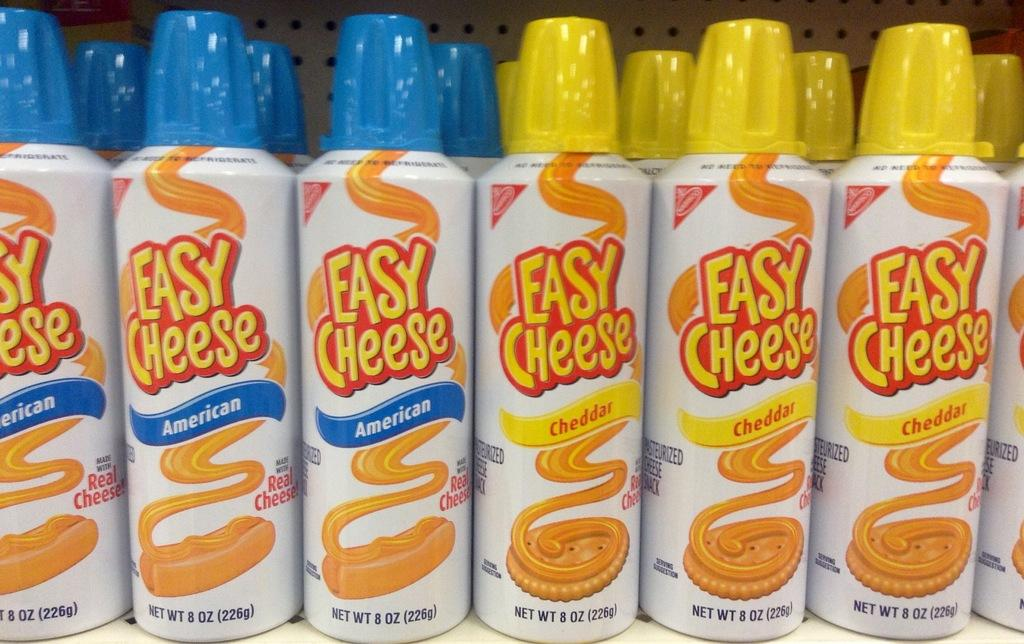What objects are present in the image? There are bottles in the image. What type of cheese is being served in the office setting in the image? There is no cheese or office setting present in the image; it only features bottles. What items are on the list in the image? There is no list present in the image; it only features bottles. 